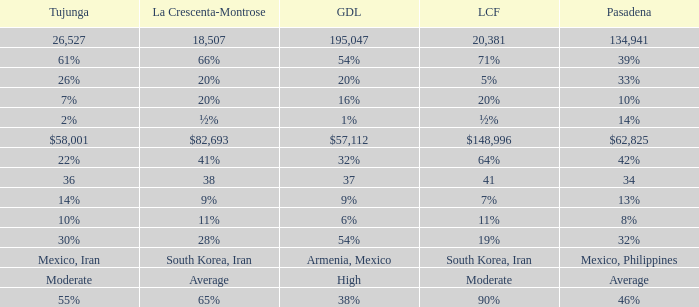When Tujunga is moderate, what is La Crescenta-Montrose? Average. 